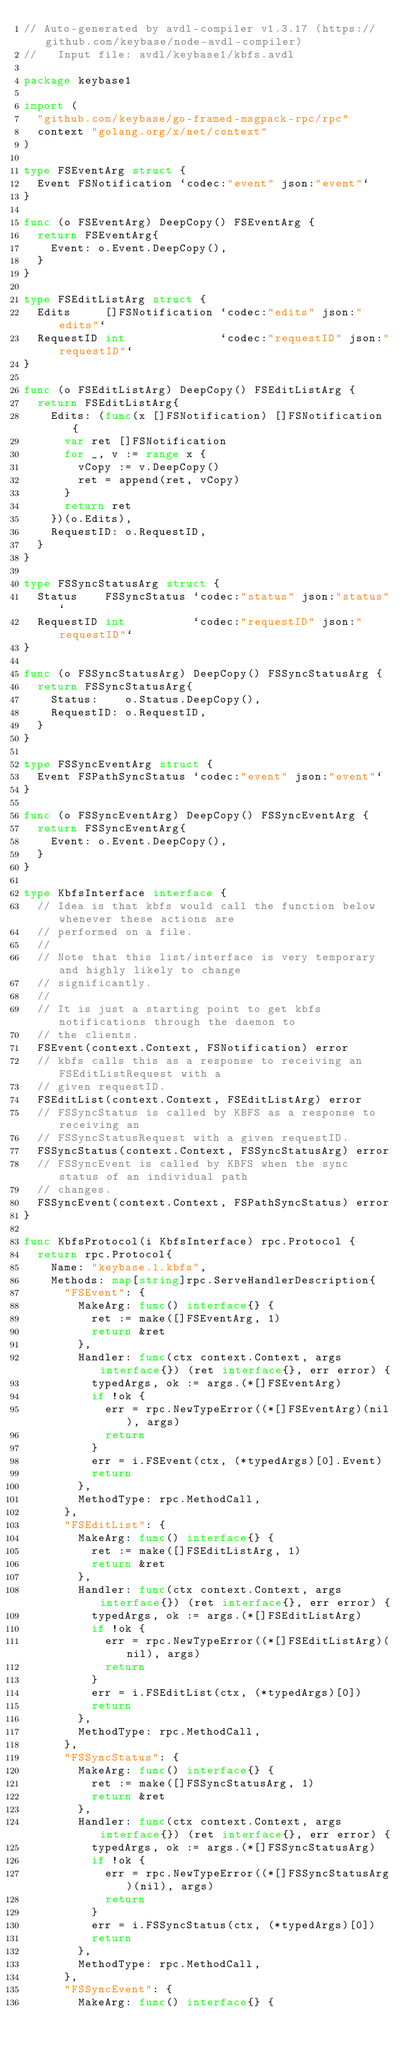<code> <loc_0><loc_0><loc_500><loc_500><_Go_>// Auto-generated by avdl-compiler v1.3.17 (https://github.com/keybase/node-avdl-compiler)
//   Input file: avdl/keybase1/kbfs.avdl

package keybase1

import (
	"github.com/keybase/go-framed-msgpack-rpc/rpc"
	context "golang.org/x/net/context"
)

type FSEventArg struct {
	Event FSNotification `codec:"event" json:"event"`
}

func (o FSEventArg) DeepCopy() FSEventArg {
	return FSEventArg{
		Event: o.Event.DeepCopy(),
	}
}

type FSEditListArg struct {
	Edits     []FSNotification `codec:"edits" json:"edits"`
	RequestID int              `codec:"requestID" json:"requestID"`
}

func (o FSEditListArg) DeepCopy() FSEditListArg {
	return FSEditListArg{
		Edits: (func(x []FSNotification) []FSNotification {
			var ret []FSNotification
			for _, v := range x {
				vCopy := v.DeepCopy()
				ret = append(ret, vCopy)
			}
			return ret
		})(o.Edits),
		RequestID: o.RequestID,
	}
}

type FSSyncStatusArg struct {
	Status    FSSyncStatus `codec:"status" json:"status"`
	RequestID int          `codec:"requestID" json:"requestID"`
}

func (o FSSyncStatusArg) DeepCopy() FSSyncStatusArg {
	return FSSyncStatusArg{
		Status:    o.Status.DeepCopy(),
		RequestID: o.RequestID,
	}
}

type FSSyncEventArg struct {
	Event FSPathSyncStatus `codec:"event" json:"event"`
}

func (o FSSyncEventArg) DeepCopy() FSSyncEventArg {
	return FSSyncEventArg{
		Event: o.Event.DeepCopy(),
	}
}

type KbfsInterface interface {
	// Idea is that kbfs would call the function below whenever these actions are
	// performed on a file.
	//
	// Note that this list/interface is very temporary and highly likely to change
	// significantly.
	//
	// It is just a starting point to get kbfs notifications through the daemon to
	// the clients.
	FSEvent(context.Context, FSNotification) error
	// kbfs calls this as a response to receiving an FSEditListRequest with a
	// given requestID.
	FSEditList(context.Context, FSEditListArg) error
	// FSSyncStatus is called by KBFS as a response to receiving an
	// FSSyncStatusRequest with a given requestID.
	FSSyncStatus(context.Context, FSSyncStatusArg) error
	// FSSyncEvent is called by KBFS when the sync status of an individual path
	// changes.
	FSSyncEvent(context.Context, FSPathSyncStatus) error
}

func KbfsProtocol(i KbfsInterface) rpc.Protocol {
	return rpc.Protocol{
		Name: "keybase.1.kbfs",
		Methods: map[string]rpc.ServeHandlerDescription{
			"FSEvent": {
				MakeArg: func() interface{} {
					ret := make([]FSEventArg, 1)
					return &ret
				},
				Handler: func(ctx context.Context, args interface{}) (ret interface{}, err error) {
					typedArgs, ok := args.(*[]FSEventArg)
					if !ok {
						err = rpc.NewTypeError((*[]FSEventArg)(nil), args)
						return
					}
					err = i.FSEvent(ctx, (*typedArgs)[0].Event)
					return
				},
				MethodType: rpc.MethodCall,
			},
			"FSEditList": {
				MakeArg: func() interface{} {
					ret := make([]FSEditListArg, 1)
					return &ret
				},
				Handler: func(ctx context.Context, args interface{}) (ret interface{}, err error) {
					typedArgs, ok := args.(*[]FSEditListArg)
					if !ok {
						err = rpc.NewTypeError((*[]FSEditListArg)(nil), args)
						return
					}
					err = i.FSEditList(ctx, (*typedArgs)[0])
					return
				},
				MethodType: rpc.MethodCall,
			},
			"FSSyncStatus": {
				MakeArg: func() interface{} {
					ret := make([]FSSyncStatusArg, 1)
					return &ret
				},
				Handler: func(ctx context.Context, args interface{}) (ret interface{}, err error) {
					typedArgs, ok := args.(*[]FSSyncStatusArg)
					if !ok {
						err = rpc.NewTypeError((*[]FSSyncStatusArg)(nil), args)
						return
					}
					err = i.FSSyncStatus(ctx, (*typedArgs)[0])
					return
				},
				MethodType: rpc.MethodCall,
			},
			"FSSyncEvent": {
				MakeArg: func() interface{} {</code> 